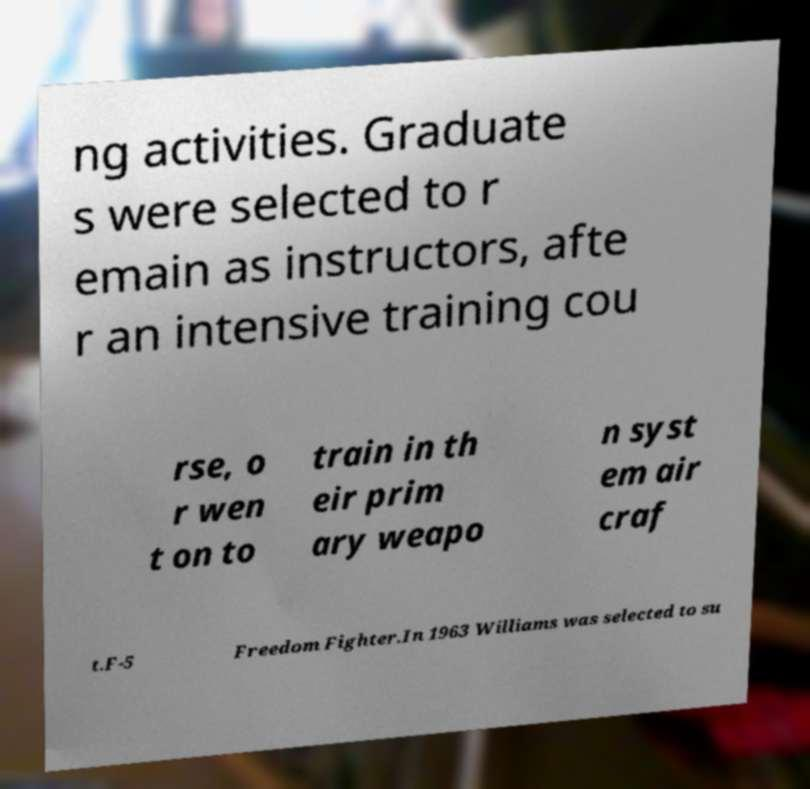I need the written content from this picture converted into text. Can you do that? ng activities. Graduate s were selected to r emain as instructors, afte r an intensive training cou rse, o r wen t on to train in th eir prim ary weapo n syst em air craf t.F-5 Freedom Fighter.In 1963 Williams was selected to su 